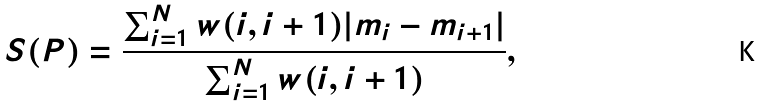<formula> <loc_0><loc_0><loc_500><loc_500>S ( P ) = \frac { \sum _ { i = 1 } ^ { N } w ( i , i + 1 ) | m _ { i } - m _ { i + 1 } | } { \sum _ { i = 1 } ^ { N } w ( i , i + 1 ) } ,</formula> 